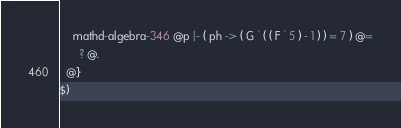<code> <loc_0><loc_0><loc_500><loc_500><_ObjectiveC_>    mathd-algebra-346 @p |- ( ph -> ( G ` ( ( F ` 5 ) - 1 ) ) = 7 ) @=
      ? @.
  @}
$)
</code> 